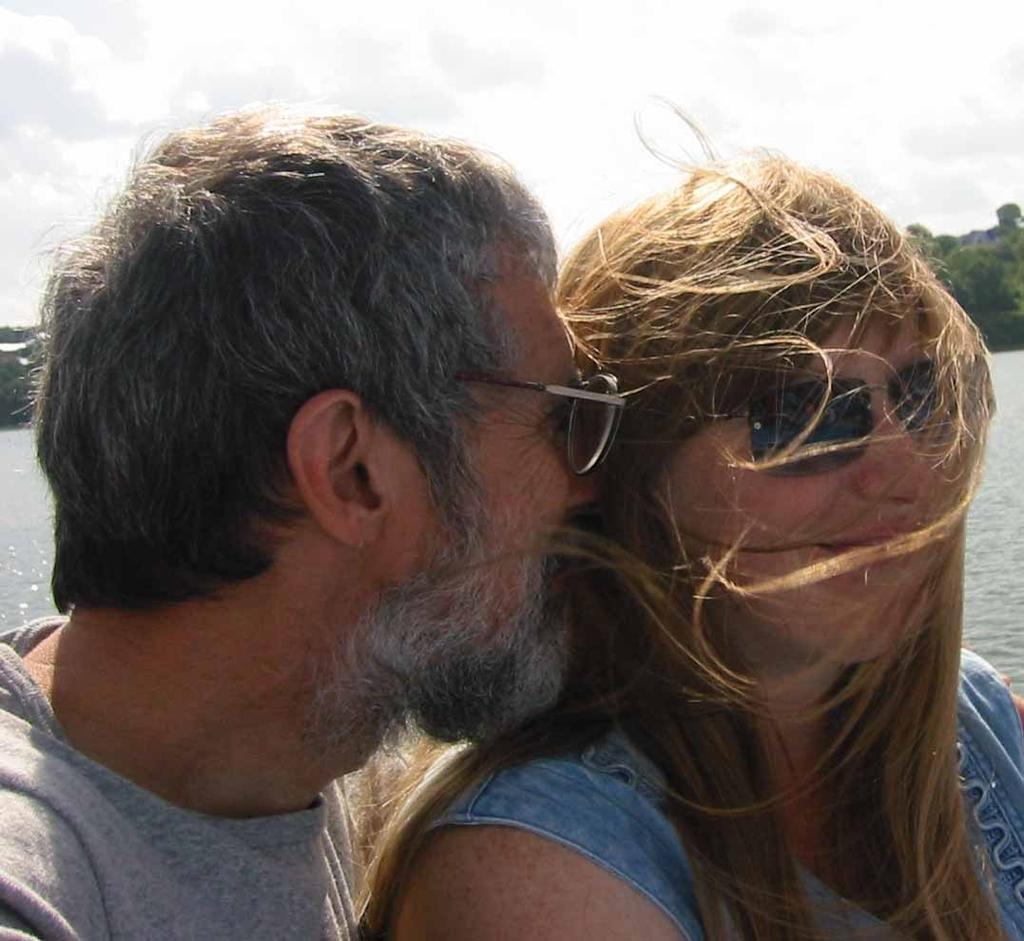Describe this image in one or two sentences. In this image we can see a man and a lady wearing glasses. In the background there is water, trees and sky. 